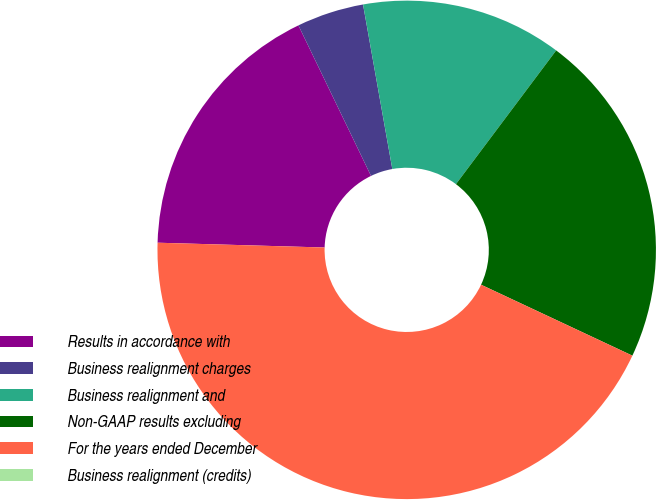Convert chart. <chart><loc_0><loc_0><loc_500><loc_500><pie_chart><fcel>Results in accordance with<fcel>Business realignment charges<fcel>Business realignment and<fcel>Non-GAAP results excluding<fcel>For the years ended December<fcel>Business realignment (credits)<nl><fcel>17.39%<fcel>4.35%<fcel>13.04%<fcel>21.74%<fcel>43.48%<fcel>0.0%<nl></chart> 